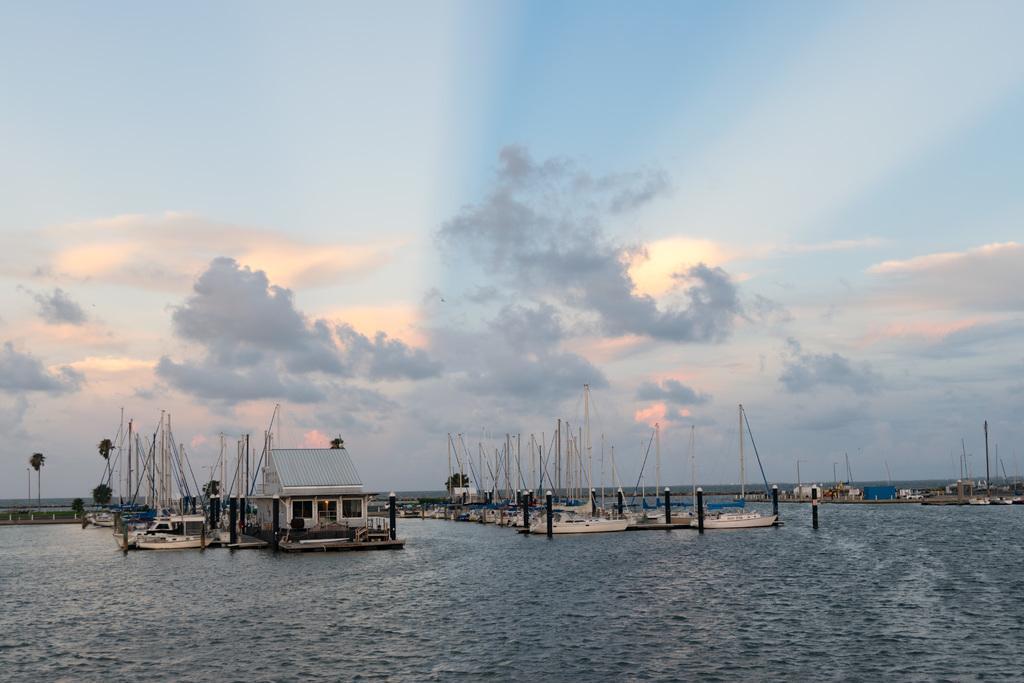Could you give a brief overview of what you see in this image? In this image we can see few boats, poles, trees and a house. In the foreground we can see the water. At the top we can see the sky. 